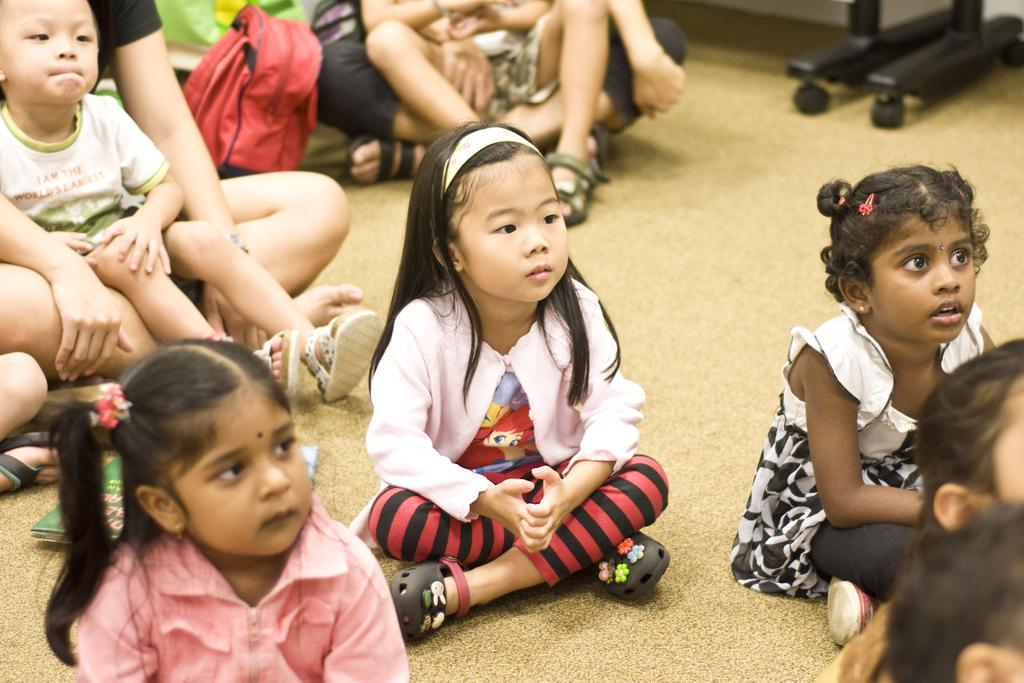Who is present in the image? There are kids in the image. What are the kids doing in the image? The kids are sitting. What is at the bottom of the image? There is a mat at the bottom of the image. What color is the string that the kids are holding in the image? There is no string present in the image; the kids are simply sitting. How many noses can be seen on the kids in the image? There is no need to count noses, as the focus is on the kids sitting in the image. 